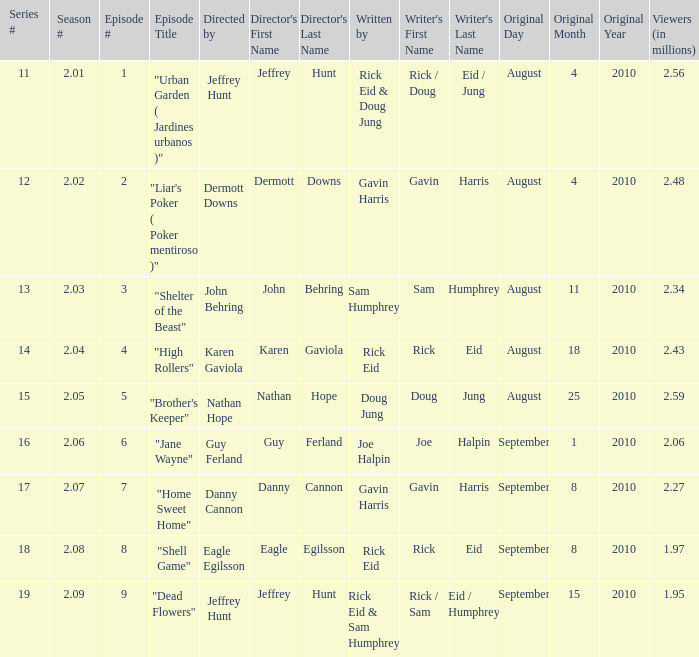What is the series minimum if the season number is 2.08? 18.0. 